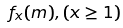<formula> <loc_0><loc_0><loc_500><loc_500>f _ { x } ( m ) , ( x \geq 1 )</formula> 